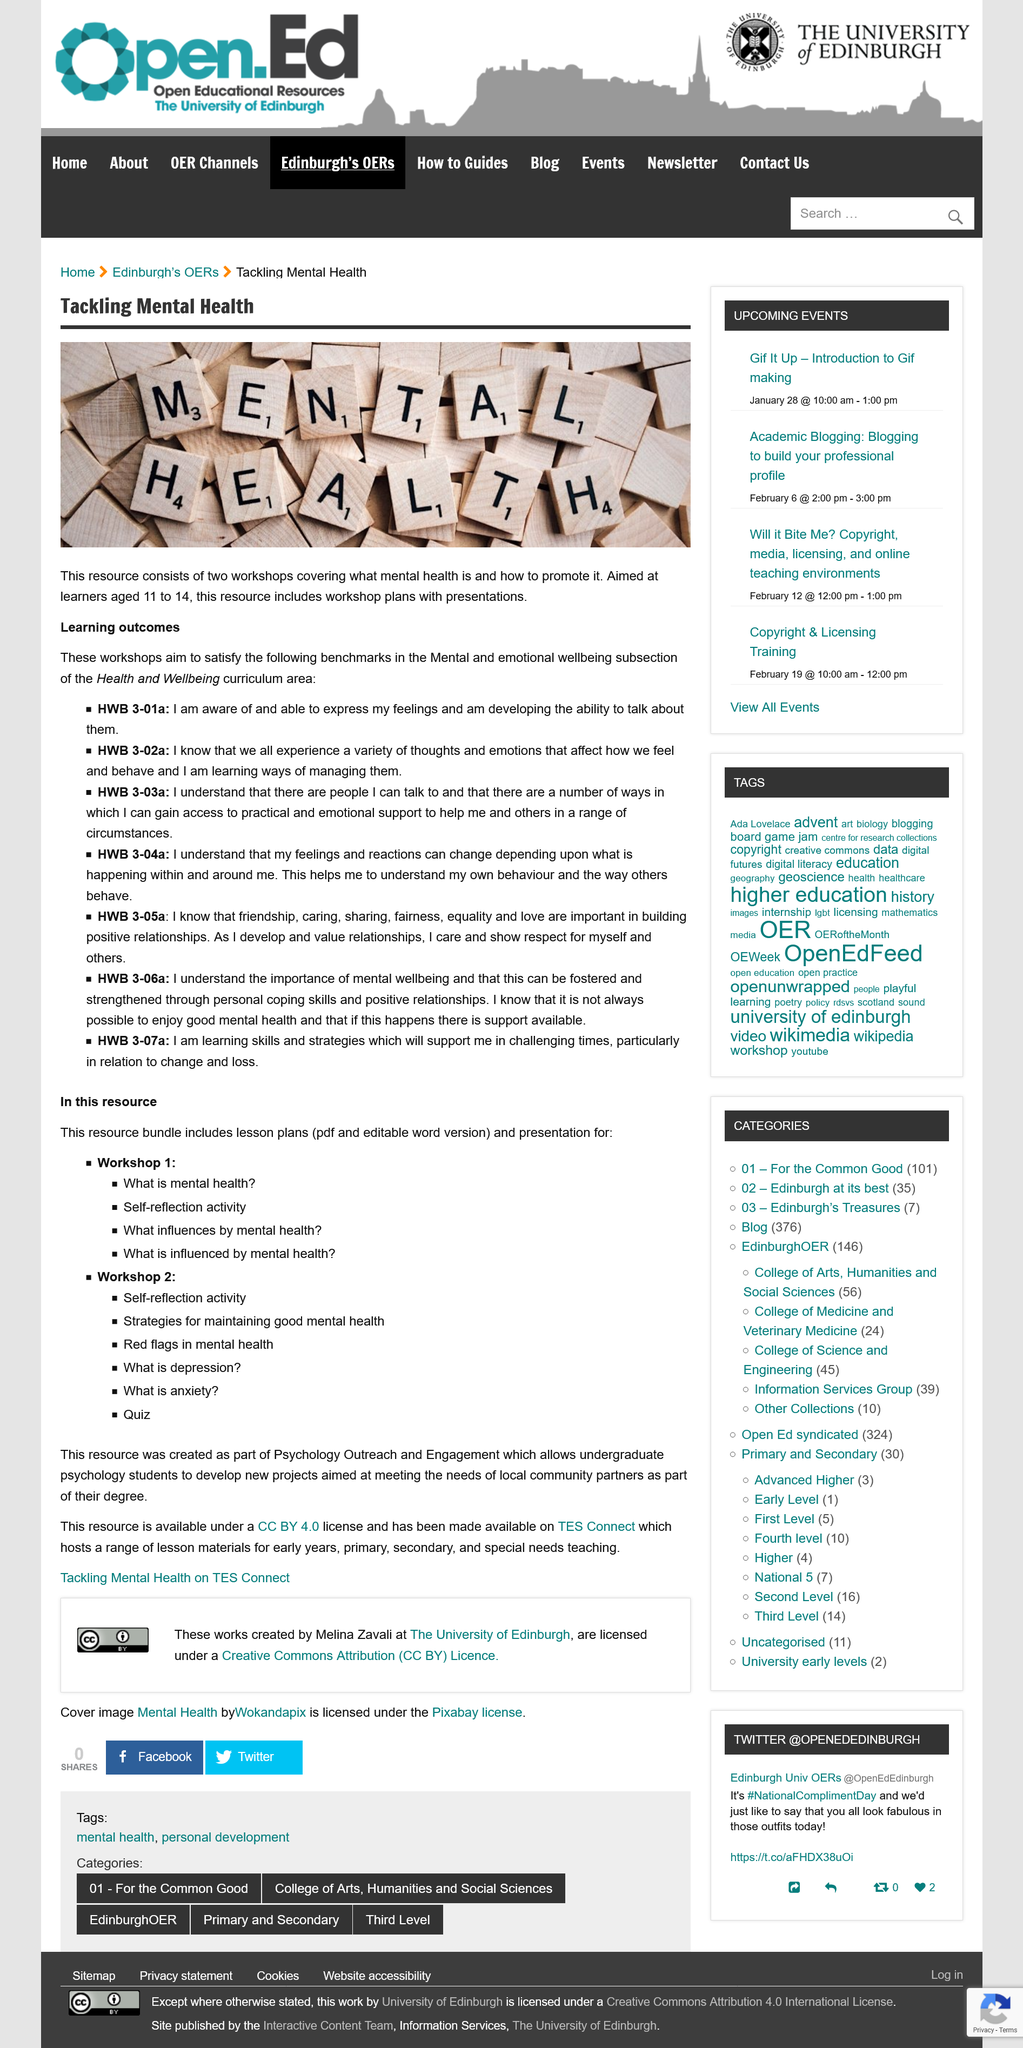Give some essential details in this illustration. I am aware of the HWB 3-01a benchmark and am able to express my feelings and am developing the ability to talk about them, as stated in the benchmark. The workshops satisfy the requirements of the mental and emotional wellbeing subsection of the Health and Wellbeing curriculum area. The workshop satisfies the HWB 3-02a benchmark. 